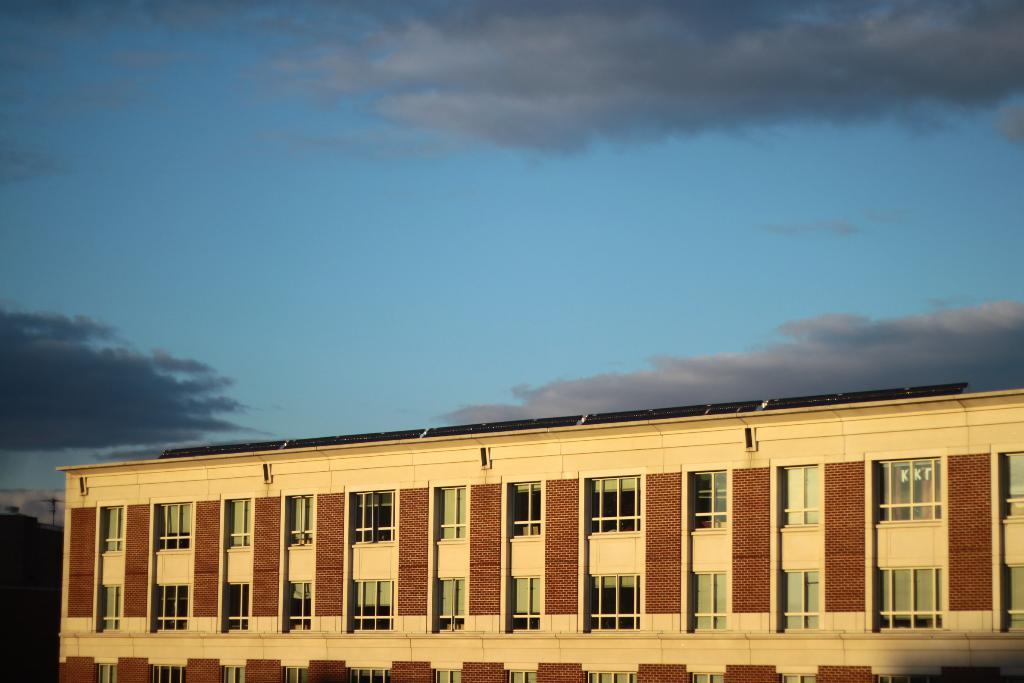Can you describe this image briefly? In this image I can see a building and windows. In the background I can see the sky. 